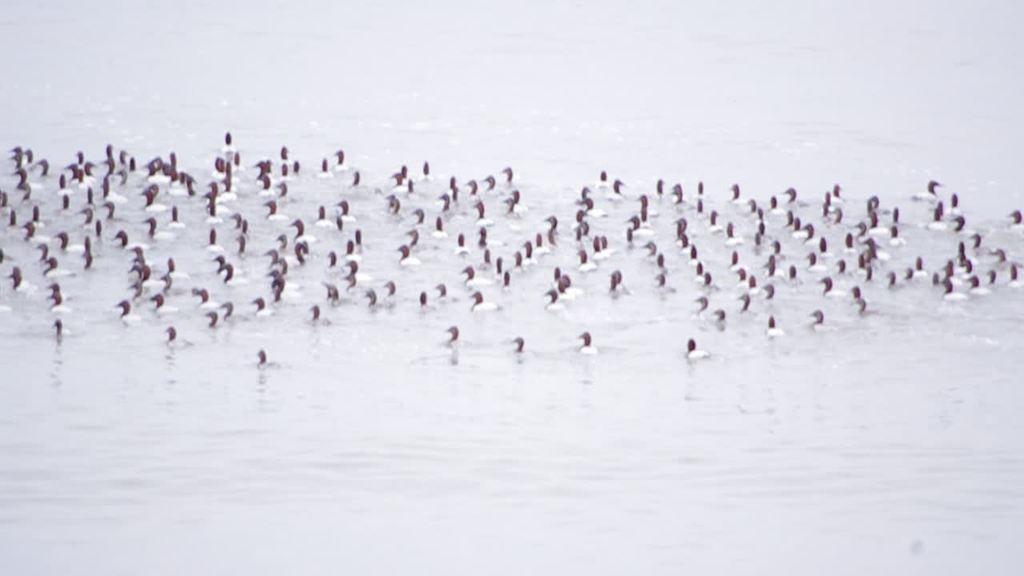Describe this image in one or two sentences. In this image I can see few birds in the water. The birds are in white and black color. 